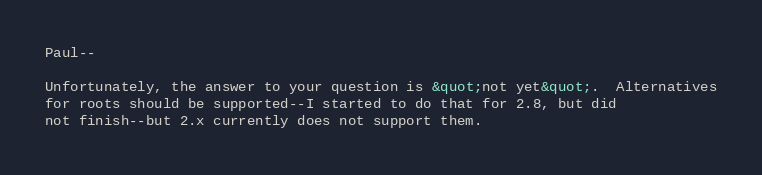<code> <loc_0><loc_0><loc_500><loc_500><_HTML_>
Paul--

Unfortunately, the answer to your question is &quot;not yet&quot;.  Alternatives
for roots should be supported--I started to do that for 2.8, but did
not finish--but 2.x currently does not support them.
</code> 